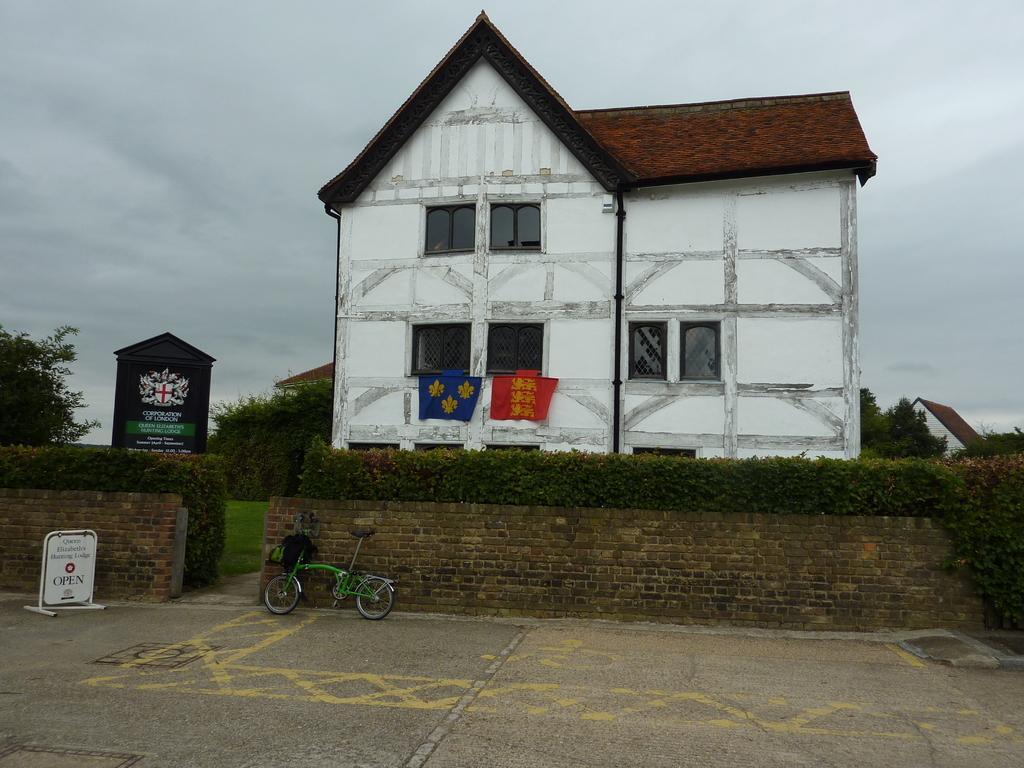Can you describe this image briefly? This picture shows a few building and we see a brick wall and few trees and couple of clothes and we see a bicycle parked and a cloudy sky. 